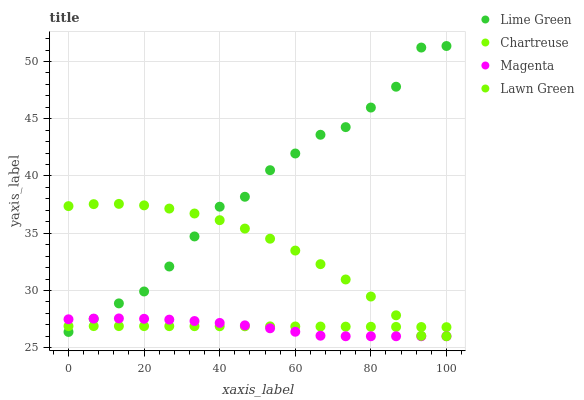Does Magenta have the minimum area under the curve?
Answer yes or no. Yes. Does Lime Green have the maximum area under the curve?
Answer yes or no. Yes. Does Chartreuse have the minimum area under the curve?
Answer yes or no. No. Does Chartreuse have the maximum area under the curve?
Answer yes or no. No. Is Chartreuse the smoothest?
Answer yes or no. Yes. Is Lime Green the roughest?
Answer yes or no. Yes. Is Lime Green the smoothest?
Answer yes or no. No. Is Chartreuse the roughest?
Answer yes or no. No. Does Lawn Green have the lowest value?
Answer yes or no. Yes. Does Lime Green have the lowest value?
Answer yes or no. No. Does Lime Green have the highest value?
Answer yes or no. Yes. Does Chartreuse have the highest value?
Answer yes or no. No. Does Chartreuse intersect Lime Green?
Answer yes or no. Yes. Is Chartreuse less than Lime Green?
Answer yes or no. No. Is Chartreuse greater than Lime Green?
Answer yes or no. No. 